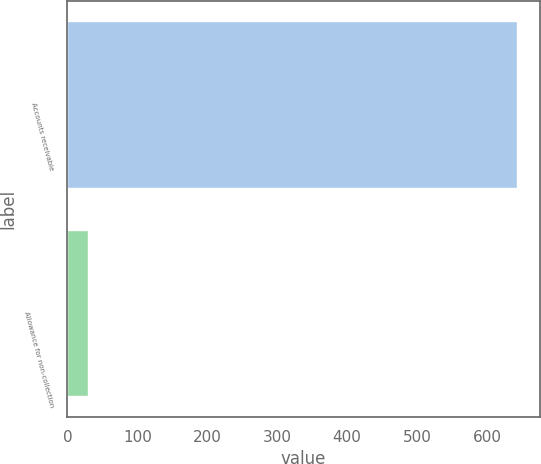Convert chart. <chart><loc_0><loc_0><loc_500><loc_500><bar_chart><fcel>Accounts receivable<fcel>Allowance for non-collection<nl><fcel>643<fcel>29<nl></chart> 